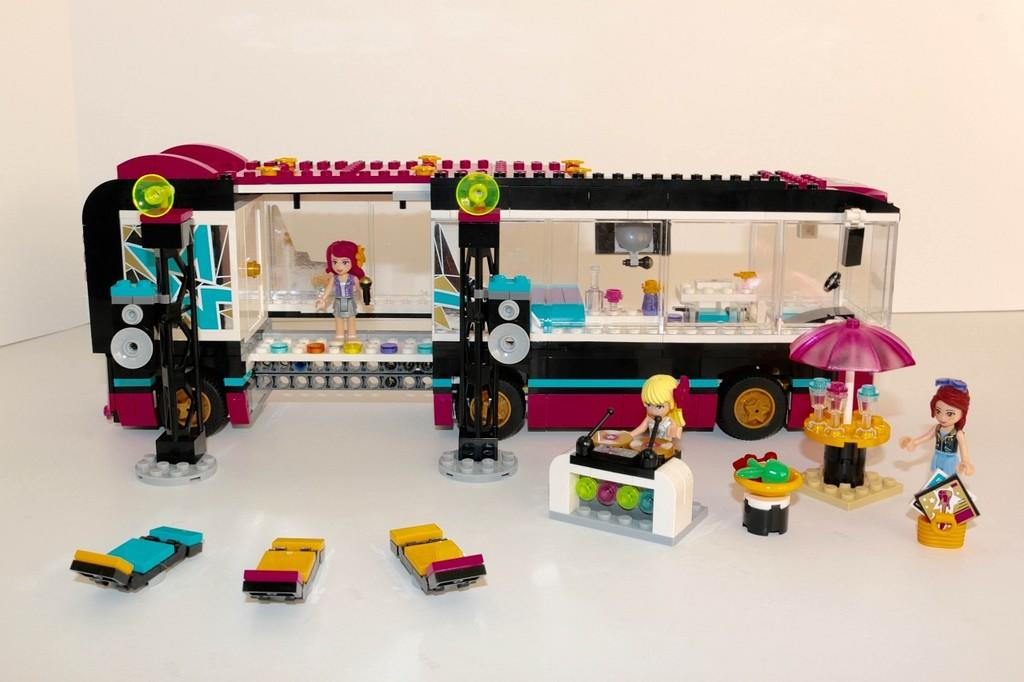What type of objects are featured in the image? There are miniatures in the image. What can be seen in the background of the image? There is a wall in the background of the image. What type of trade is being conducted in the image? There is no indication of any trade being conducted in the image; it features miniatures and a wall in the background. How does the house in the image affect the throat of the person in the image? There is no house or person present in the image, so it is not possible to determine any effect on a throat. 